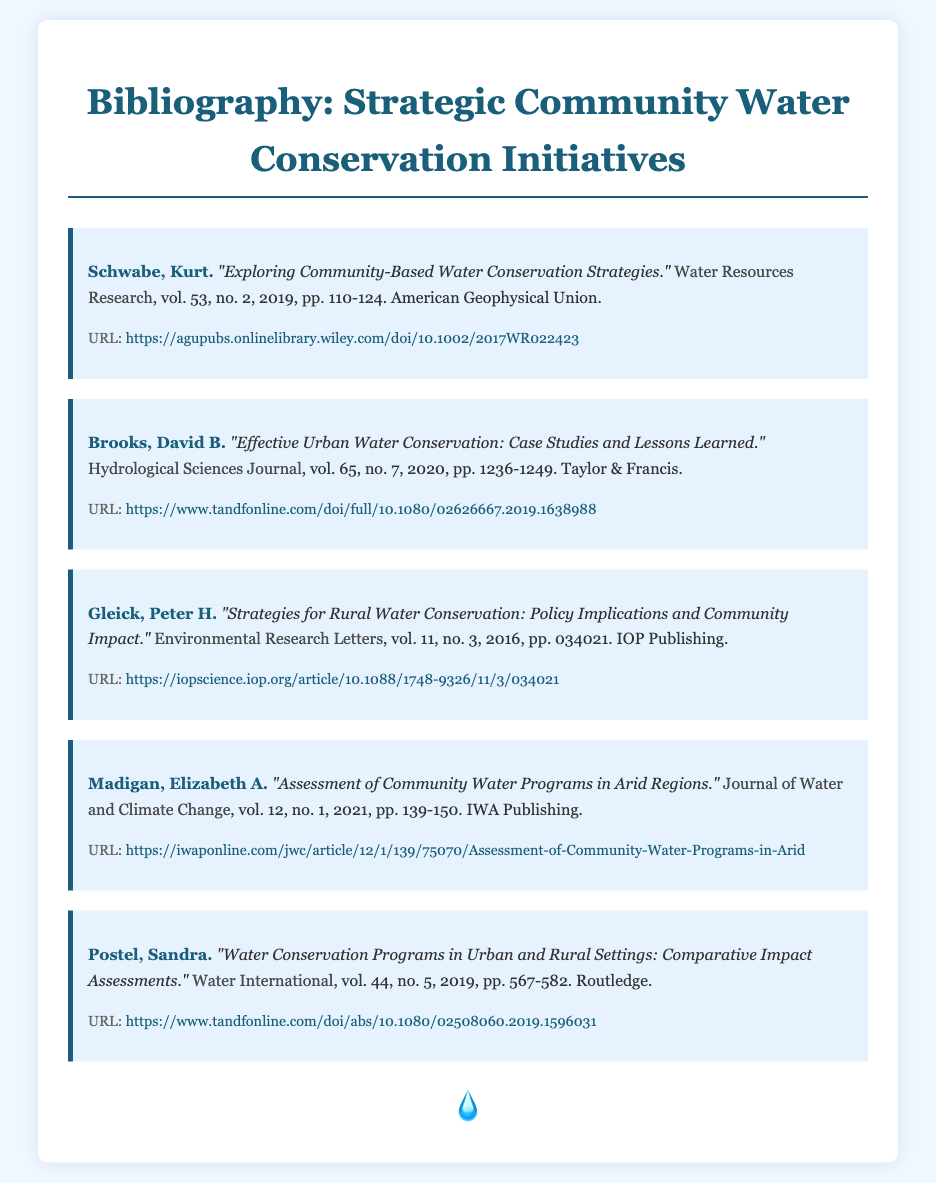what is the title of the first item in the bibliography? The title of the first item is found in the document's first bibliography entry.
Answer: "Exploring Community-Based Water Conservation Strategies." who is the author of the article "Effective Urban Water Conservation: Case Studies and Lessons Learned"? The author's name can be found at the beginning of the specific entry in the bibliography.
Answer: David B. Brooks what is the volume number of the journal "Environmental Research Letters" where Gleick's article was published? The volume number is stated in the reference provided for Gleick's article.
Answer: 11 how many pages does Elizabeth A. Madigan's article cover? The page range is specified in the citation details for Madigan's article.
Answer: 139-150 which journal published the article by Postel in 2019? The journal's name is included in the reference details for Postel's article.
Answer: Water International what year was the article "Strategies for Rural Water Conservation: Policy Implications and Community Impact" published? The publication year is explicitly stated in the citation for Gleick's article.
Answer: 2016 which organization published the article by Kurt Schwabe? The publisher's name can be found at the end of Schwabe's bibliography entry.
Answer: American Geophysical Union what is the URI for the article by Brooks? The URL is provided as part of the details in Brooks' bibliography entry.
Answer: https://www.tandfonline.com/doi/full/10.1080/02626667.2019.1638988 how many items are included in the bibliography? The total number of items can be counted from the entries in the bibliography section.
Answer: 5 